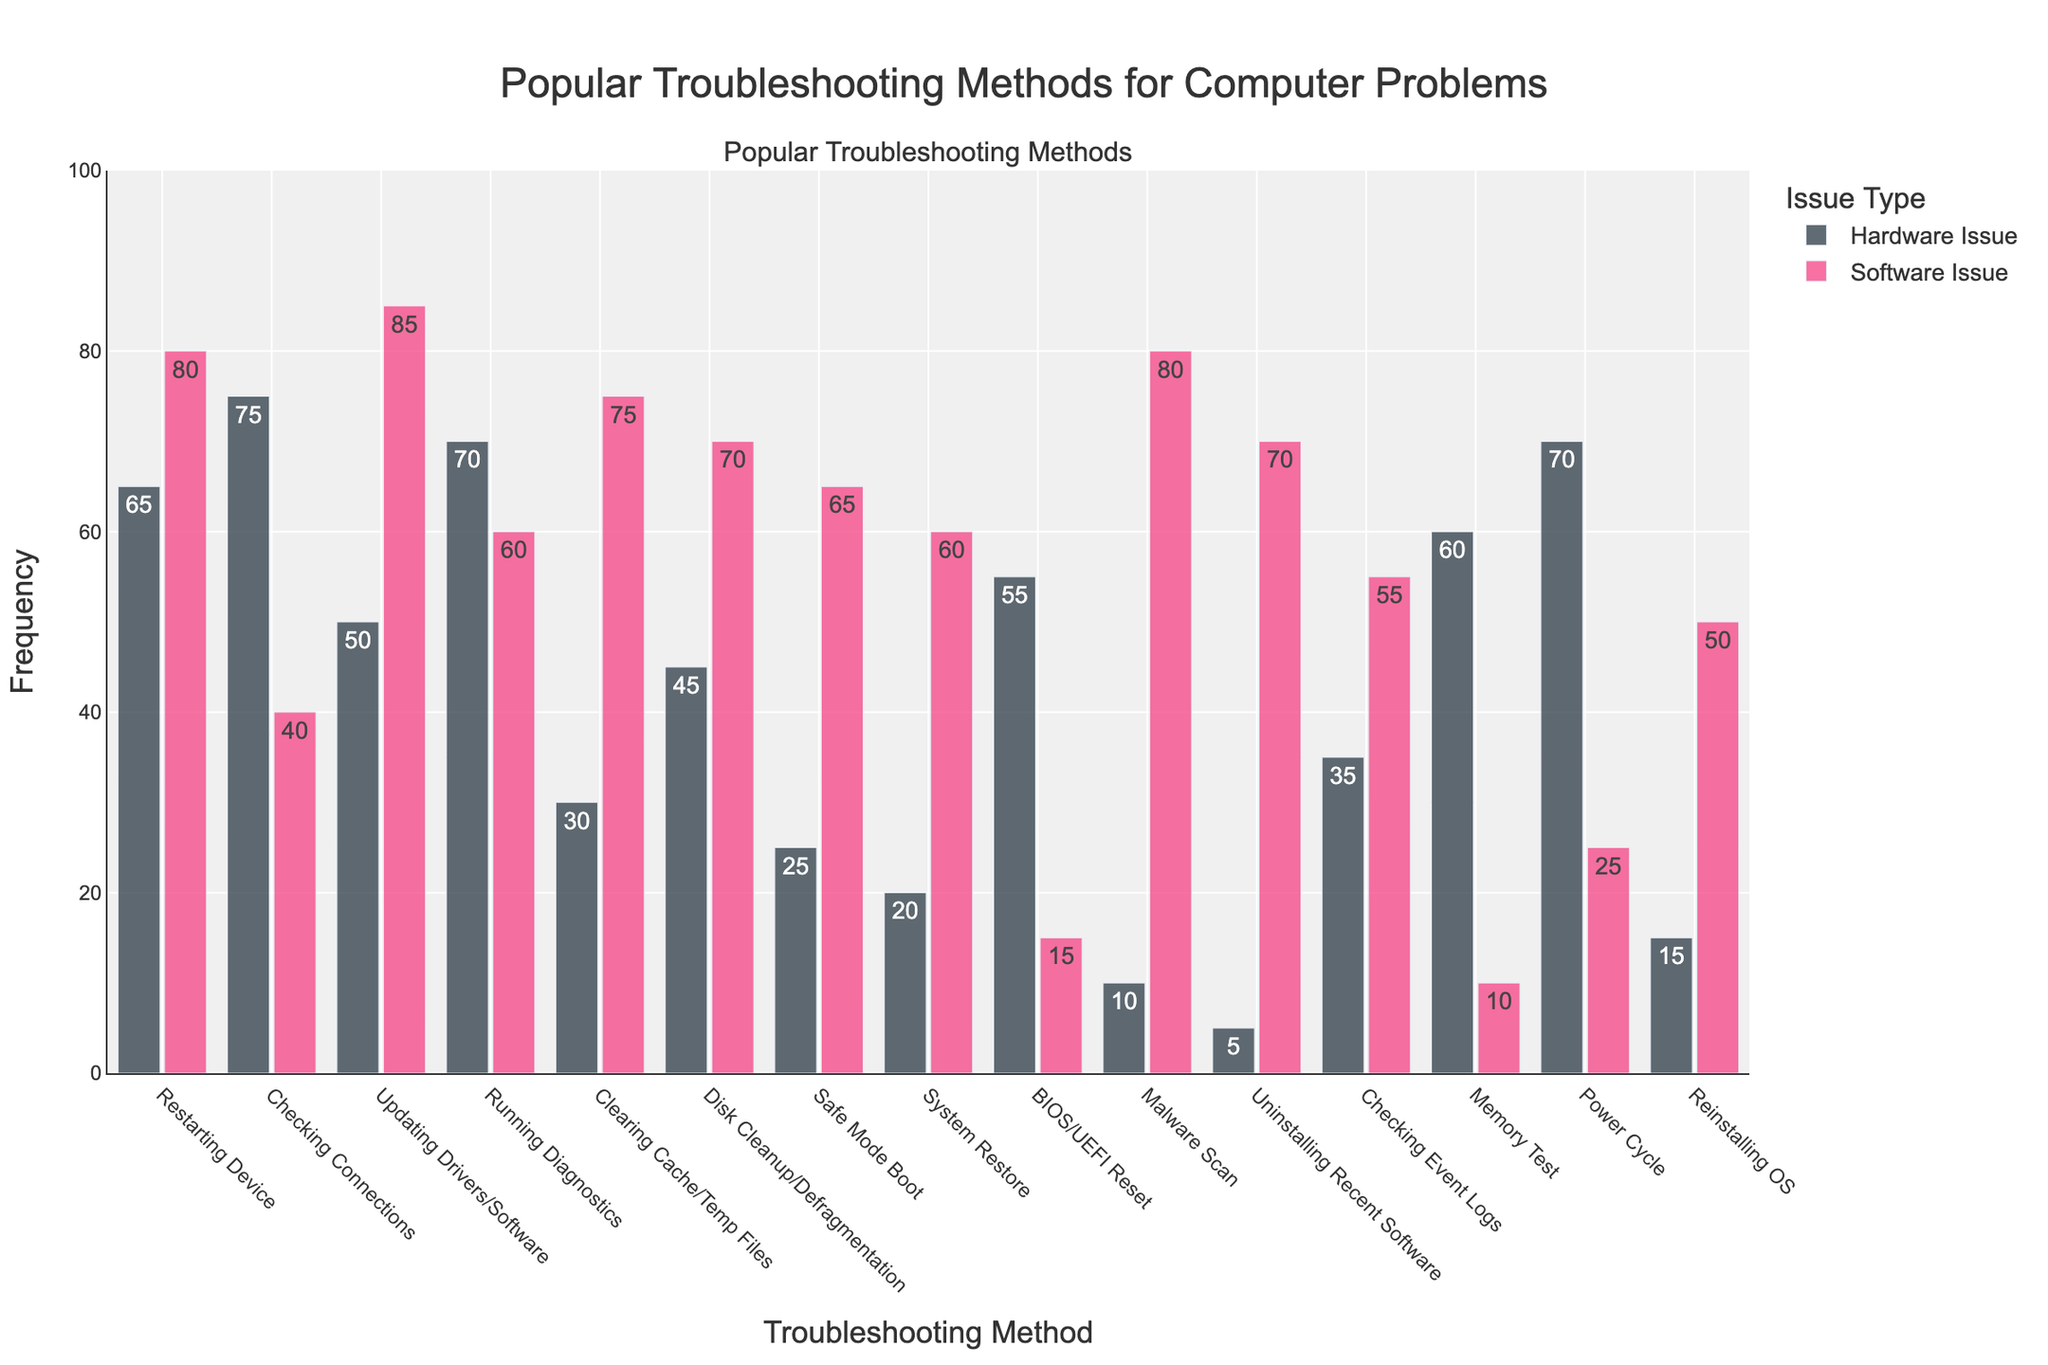What is the most popular troubleshooting method for hardware issues? By looking at the heights of the bars representing hardware issues, the highest bar corresponds to "Checking Connections", indicating it is the most popular method.
Answer: Checking Connections Which troubleshooting method has the biggest difference in popularity between hardware and software issues? To find the method with the biggest difference, we should compute the absolute differences between Hardware and Software Issue counts for each method. "BIOS/UEFI Reset" has the highest difference (55 for hardware - 15 for software = 40).
Answer: BIOS/UEFI Reset What is the least common troubleshooting method for hardware issues and how frequently is it used? The shortest bar representing hardware issues indicates this method. "Uninstalling Recent Software" has the shortest bar with a count of 5.
Answer: Uninstalling Recent Software, 5 Between "Clearing Cache/Temp Files" and "System Restore", which one is used more frequently for software issues? By comparing the heights of the bars for software issues, "Clearing Cache/Temp Files" has a higher bar than "System Restore".
Answer: Clearing Cache/Temp Files Are hardware or software issues more frequently resolved by running diagnostics? Compare the bars for "Running Diagnostics", the software issues bar is shorter (60) compared to the hardware issues bar (70).
Answer: Hardware issues Which troubleshooting method has the smallest popularity for software issues? By identifying the shortest bar representing software issues, "Memory Test" has the shortest bar with a count of 10.
Answer: Memory Test What is the combined frequency of using "Restarting Device" and "Power Cycle" for hardware issues? Summing the frequencies: "Restarting Device" (65) + "Power Cycle" (70) equals 135.
Answer: 135 For which issue type, hardware or software, is "Updating Drivers/Software" more commonly used? By comparing the bars, "Updating Drivers/Software" is more frequently used in software issues (85) than hardware issues (50).
Answer: Software issues Which troubleshooting method has closer frequencies between hardware and software issues? By checking methods, "Running Diagnostics" shows closer frequencies (70 for hardware and 60 for software) with a difference of 10.
Answer: Running Diagnostics Are more methods used above or below the 50 frequency mark for software issues? Identify the methods with bars above 50 for software issues: "Restarting Device", "Updating Drivers/Software", "Clearing Cache/Temp Files", "Disk Cleanup/Defragmentation", "Safe Mode Boot", "System Restore", "Malware Scan", "Uninstalling Recent Software", "Checking Event Logs". There are 9 methods above 50. Below 50, there are 6 methods.
Answer: Above 